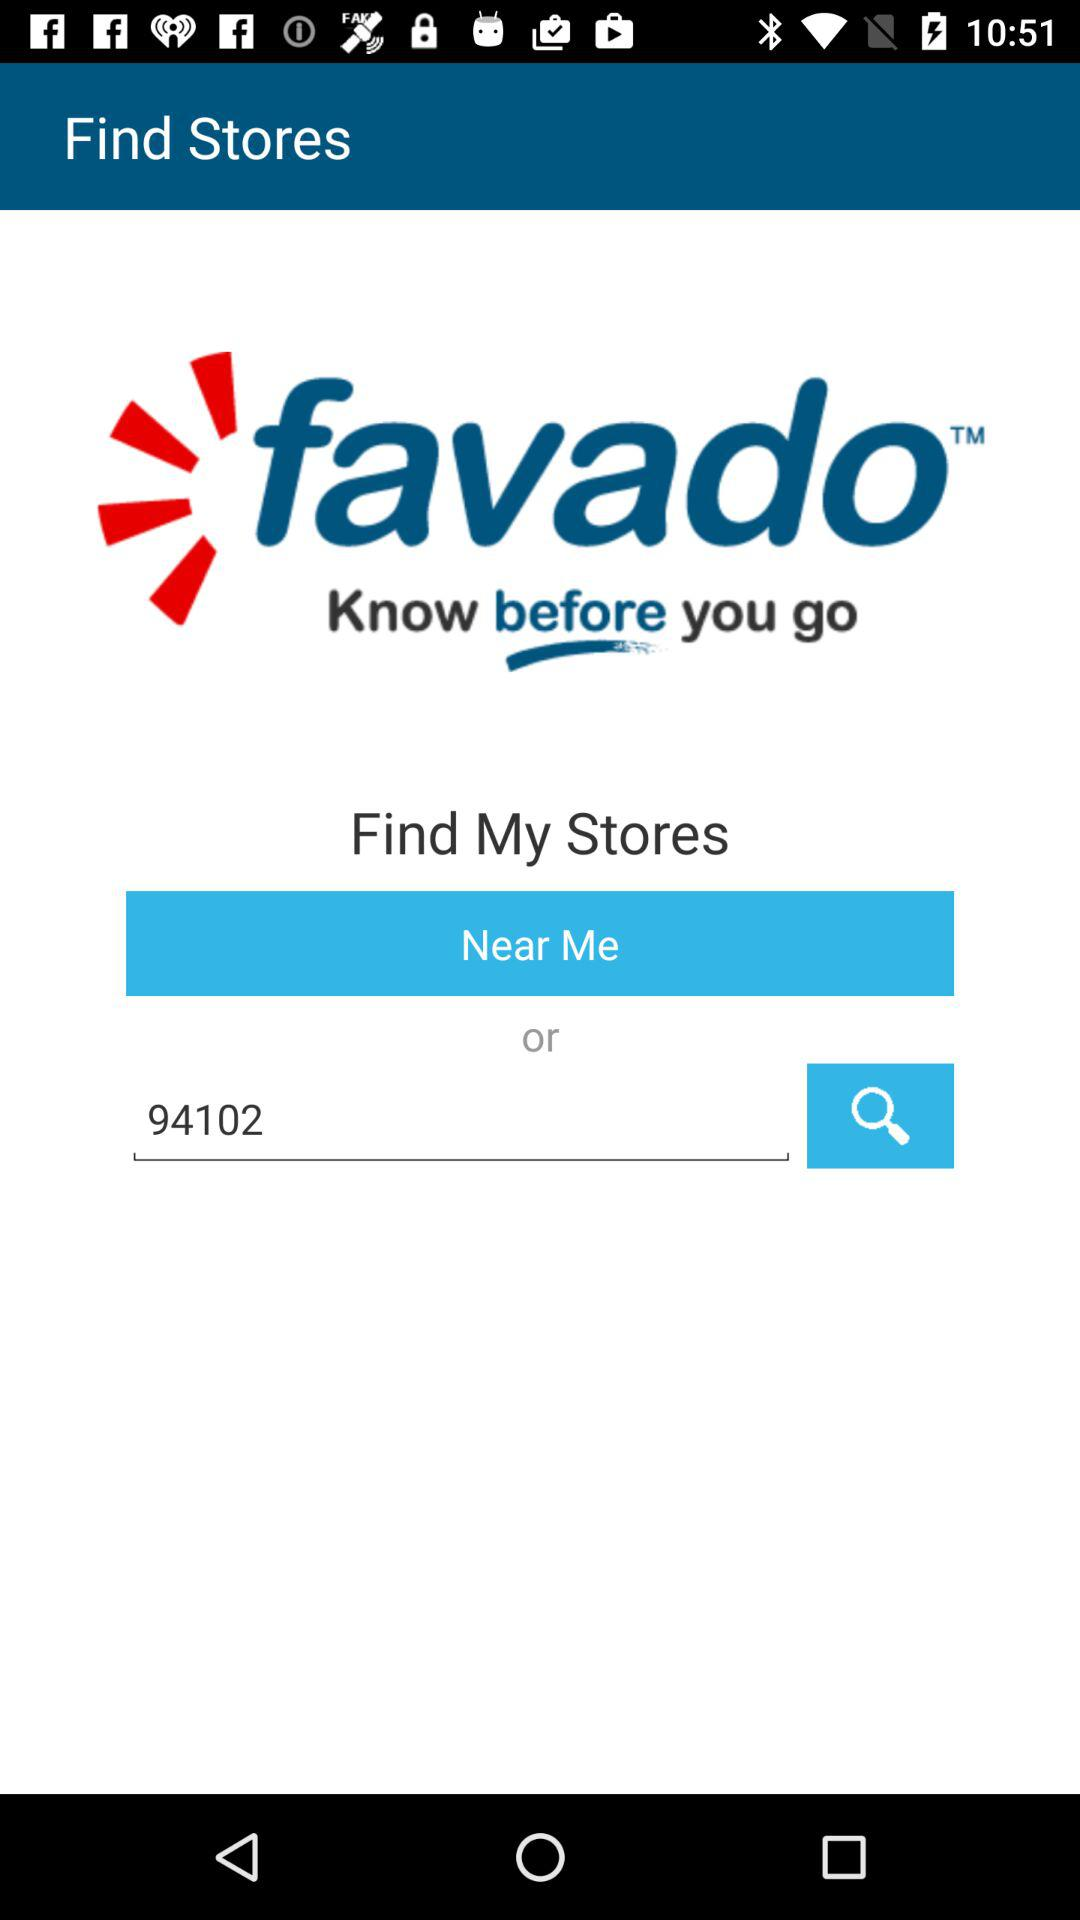What is the name of the application? The name of the application is "favado™ Know before you go". 